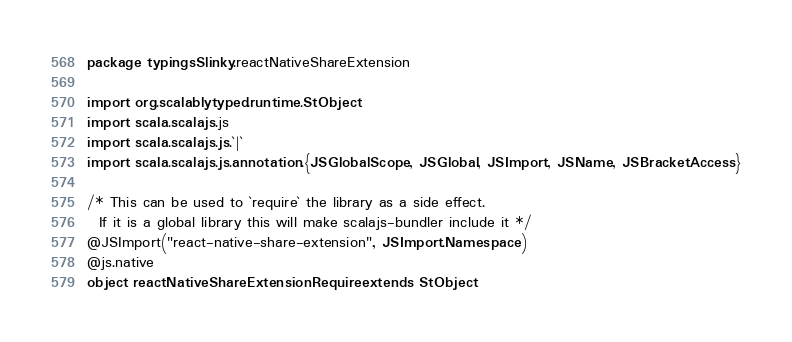Convert code to text. <code><loc_0><loc_0><loc_500><loc_500><_Scala_>package typingsSlinky.reactNativeShareExtension

import org.scalablytyped.runtime.StObject
import scala.scalajs.js
import scala.scalajs.js.`|`
import scala.scalajs.js.annotation.{JSGlobalScope, JSGlobal, JSImport, JSName, JSBracketAccess}

/* This can be used to `require` the library as a side effect.
  If it is a global library this will make scalajs-bundler include it */
@JSImport("react-native-share-extension", JSImport.Namespace)
@js.native
object reactNativeShareExtensionRequire extends StObject
</code> 